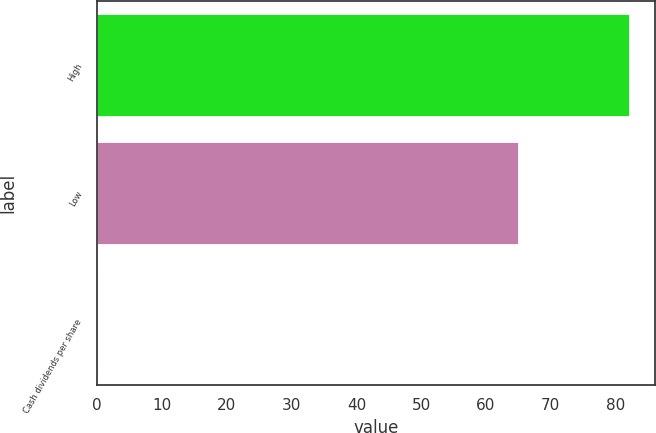<chart> <loc_0><loc_0><loc_500><loc_500><bar_chart><fcel>High<fcel>Low<fcel>Cash dividends per share<nl><fcel>82.03<fcel>64.87<fcel>0.13<nl></chart> 